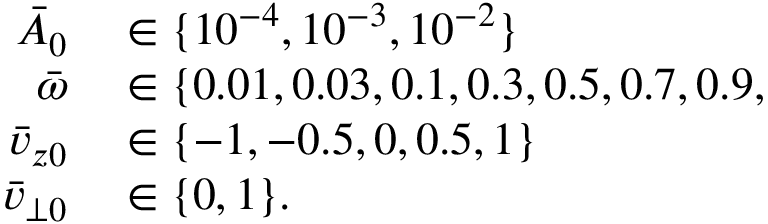Convert formula to latex. <formula><loc_0><loc_0><loc_500><loc_500>\begin{array} { r l } { \bar { A } _ { 0 } } & \in \{ 1 0 ^ { - 4 } , 1 0 ^ { - 3 } , 1 0 ^ { - 2 } \} } \\ { \bar { \omega } } & \in \{ 0 . 0 1 , 0 . 0 3 , 0 . 1 , 0 . 3 , 0 . 5 , 0 . 7 , 0 . 9 , } \\ { \bar { v } _ { z 0 } } & \in \{ - 1 , - 0 . 5 , 0 , 0 . 5 , 1 \} } \\ { \bar { v } _ { \perp 0 } } & \in \{ 0 , 1 \} . } \end{array}</formula> 